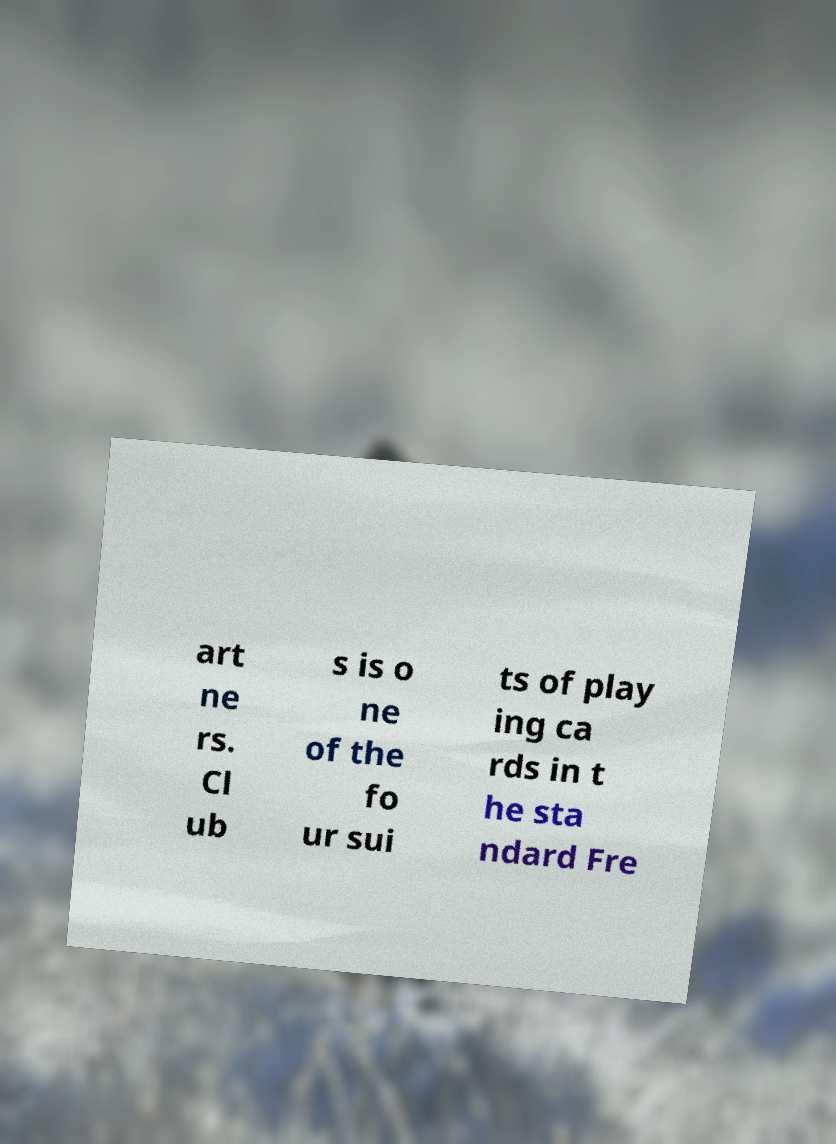What messages or text are displayed in this image? I need them in a readable, typed format. art ne rs. Cl ub s is o ne of the fo ur sui ts of play ing ca rds in t he sta ndard Fre 